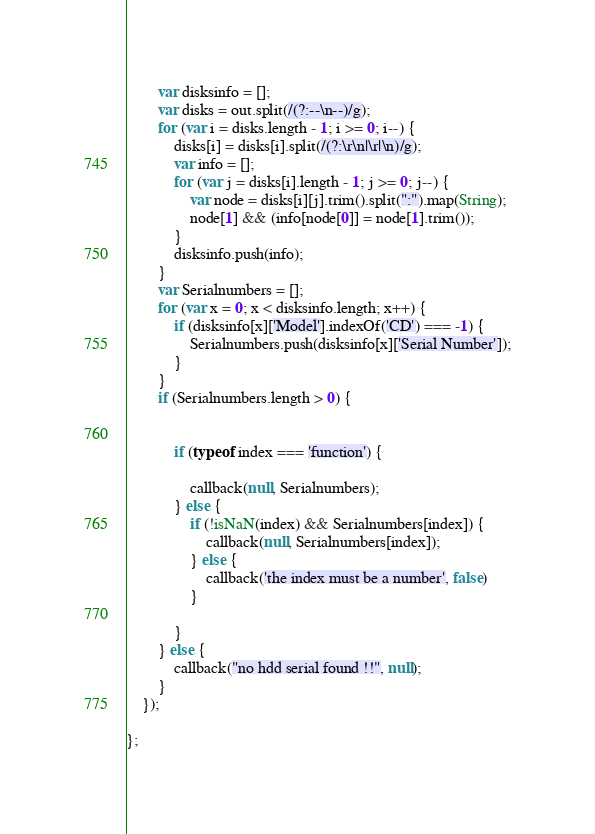<code> <loc_0><loc_0><loc_500><loc_500><_JavaScript_>        var disksinfo = [];
        var disks = out.split(/(?:--\n--)/g);
        for (var i = disks.length - 1; i >= 0; i--) {
            disks[i] = disks[i].split(/(?:\r\n|\r|\n)/g);
            var info = [];
            for (var j = disks[i].length - 1; j >= 0; j--) {
                var node = disks[i][j].trim().split(":").map(String);
                node[1] && (info[node[0]] = node[1].trim());
            }
            disksinfo.push(info);
        }
        var Serialnumbers = [];
        for (var x = 0; x < disksinfo.length; x++) {
            if (disksinfo[x]['Model'].indexOf('CD') === -1) {
                Serialnumbers.push(disksinfo[x]['Serial Number']);
            }
        }
        if (Serialnumbers.length > 0) {


            if (typeof index === 'function') {

                callback(null, Serialnumbers);
            } else {
                if (!isNaN(index) && Serialnumbers[index]) {
                    callback(null, Serialnumbers[index]);
                } else {
                    callback('the index must be a number', false)
                }

            }
        } else {
            callback("no hdd serial found !!", null);
        }
    });

};</code> 